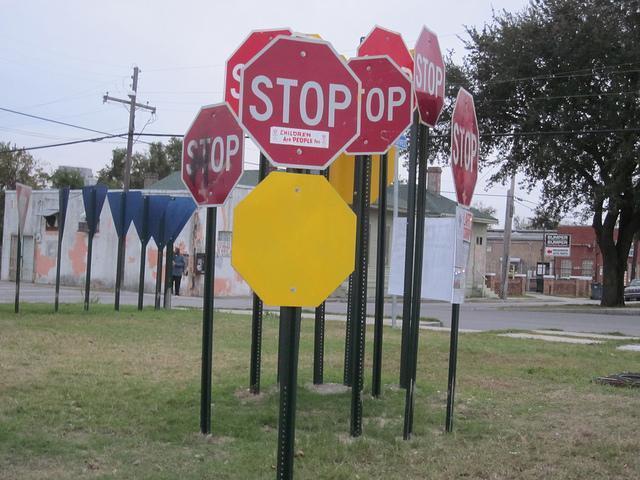How many stops signs are in the picture?
Give a very brief answer. 7. How many stop signs are there?
Give a very brief answer. 7. How many stop signs can be seen?
Give a very brief answer. 6. How many laptops are visible?
Give a very brief answer. 0. 